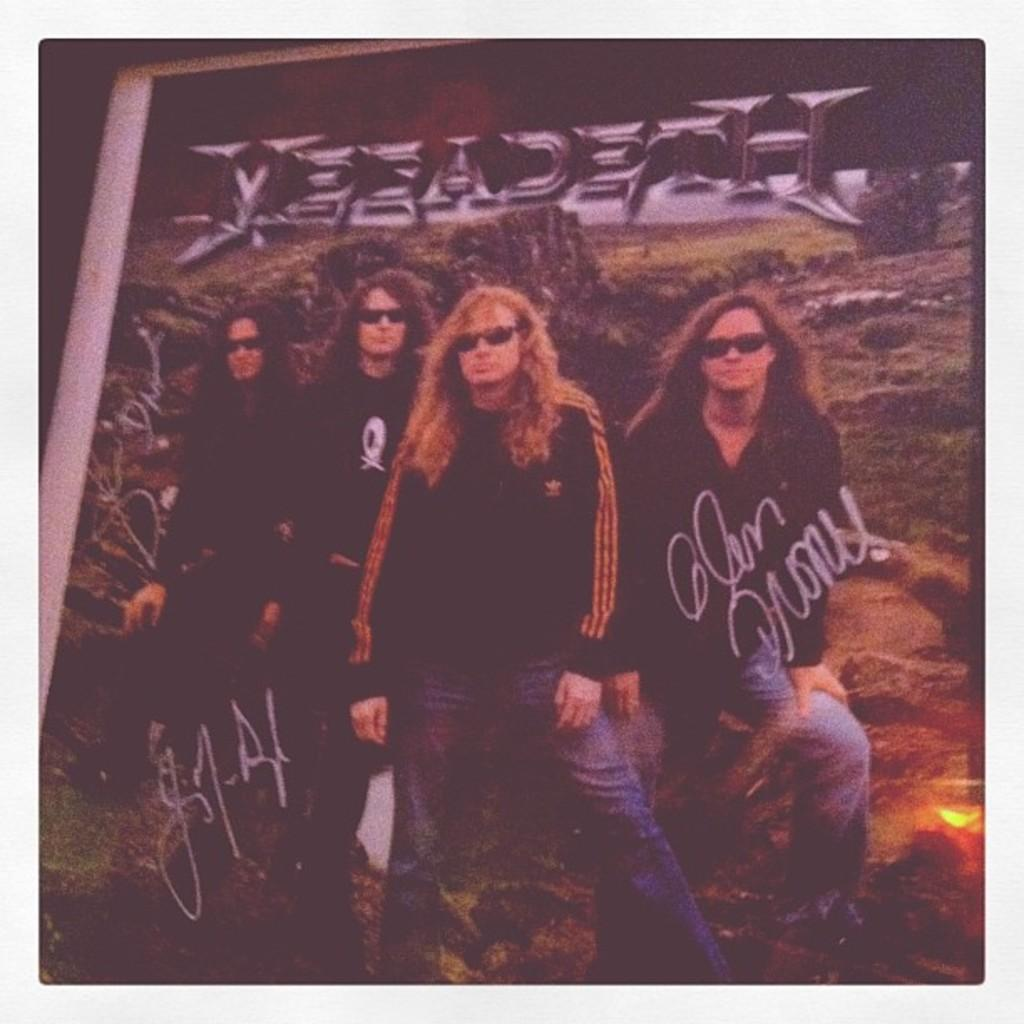How many people are in the image? There are four persons in the image. Where are the persons located in the image? The persons are standing in the middle of the image. What is written at the top of the image? There is text written at the top of the image. What type of protest is taking place in the image? There is no protest present in the image; it features four persons standing in the middle of the image. What time of day is it in the image, considering the presence of a chess game? There is no chess game present in the image, so it cannot be determined what time of day it is. 